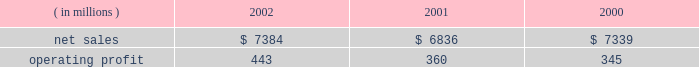Lockheed martin corporation management 2019s discussion and analysis of financial condition and results of operations december 31 , 2002 space systems space systems 2019 operating results included the following : ( in millions ) 2002 2001 2000 .
Net sales for space systems increased by 8% ( 8 % ) in 2002 compared to 2001 .
The increase in sales for 2002 resulted from higher volume in government space of $ 370 million and commercial space of $ 180 million .
In government space , increases of $ 470 million in government satellite programs and $ 130 million in ground systems activities more than offset volume declines of $ 175 million on government launch vehi- cles and $ 55 million on strategic missile programs .
The increase in commercial space sales is primarily attributable to an increase in launch vehicle activities , with nine commercial launches during 2002 compared to six in 2001 .
Net sales for the segment decreased by 7% ( 7 % ) in 2001 com- pared to 2000 .
The decrease in sales for 2001 resulted from volume declines in commercial space of $ 560 million , which more than offset increases in government space of $ 60 million .
In commercial space , sales declined due to volume reductions of $ 480 million in commercial launch vehicle activities and $ 80 million in satellite programs .
There were six launches in 2001 compared to 14 launches in 2000 .
The increase in gov- ernment space resulted from a combined increase of $ 230 mil- lion related to higher volume on government satellite programs and ground systems activities .
These increases were partially offset by a $ 110 million decrease related to volume declines in government launch vehicle activity , primarily due to program maturities , and by $ 50 million due to the absence in 2001 of favorable adjustments recorded on the titan iv pro- gram in 2000 .
Operating profit for the segment increased 23% ( 23 % ) in 2002 as compared to 2001 , mainly driven by the commercial space business .
Reduced losses in commercial space during 2002 resulted in increased operating profit of $ 90 million when compared to 2001 .
Commercial satellite manufacturing losses declined $ 100 million in 2002 as operating performance improved and satellite deliveries increased .
In the first quarter of 2001 , a $ 40 million loss provision was recorded on certain commercial satellite manufacturing contracts .
Due to the industry-wide oversupply and deterioration of pricing in the commercial launch market , financial results on commercial launch vehicles continue to be challenging .
During 2002 , this trend led to a decline in operating profit of $ 10 million on commercial launch vehicles when compared to 2001 .
This decrease was primarily due to lower profitability of $ 55 mil- lion on the three additional launches in the current year , addi- tional charges of $ 60 million ( net of a favorable contract adjustment of $ 20 million ) for market and pricing pressures and included the adverse effect of a $ 35 million adjustment for commercial launch vehicle contract settlement costs .
The 2001 results also included charges for market and pricing pressures , which reduced that year 2019s operating profit by $ 145 million .
The $ 10 million decrease in government space 2019s operating profit for the year is primarily due to the reduced volume on government launch vehicles and strategic missile programs , which combined to decrease operating profit by $ 80 million , partially offset by increases of $ 40 million in government satellite programs and $ 30 million in ground systems activities .
Operating profit for the segment increased by 4% ( 4 % ) in 2001 compared to 2000 .
Operating profit increased in 2001 due to a $ 35 million increase in government space partially offset by higher year-over-year losses of $ 20 million in commercial space .
In government space , operating profit increased due to the impact of higher volume and improved performance in ground systems and government satellite programs .
The year- to-year comparison of operating profit was not affected by the $ 50 million favorable titan iv adjustment recorded in 2000 discussed above , due to a $ 55 million charge related to a more conservative assessment of government launch vehi- cle programs that was recorded in the fourth quarter of 2000 .
In commercial space , decreased operating profit of $ 15 mil- lion on launch vehicles more than offset lower losses on satel- lite manufacturing activities .
The commercial launch vehicle operating results included $ 60 million in higher charges for market and pricing pressures when compared to 2000 .
These negative adjustments were partially offset by $ 50 million of favorable contract adjustments on certain launch vehicle con- tracts .
Commercial satellite manufacturing losses decreased slightly from 2000 and included the adverse impact of a $ 40 million loss provision recorded in the first quarter of 2001 for certain commercial satellite contracts related to schedule and technical issues. .
What was the average operating profit from 2000 to 2003? 
Computations: (((443 + 360) + 345) / 3)
Answer: 382.66667. 